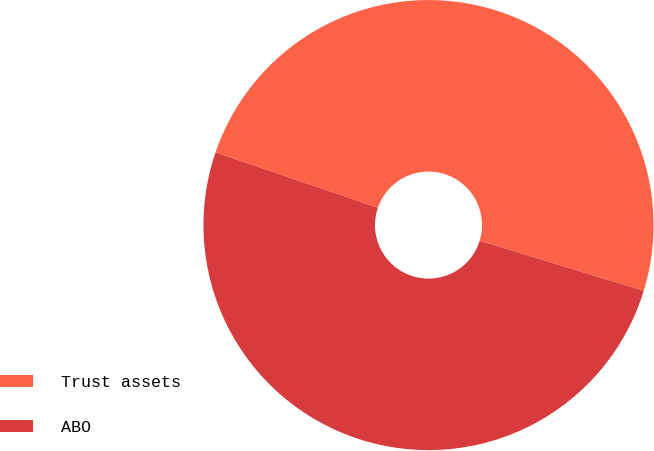Convert chart to OTSL. <chart><loc_0><loc_0><loc_500><loc_500><pie_chart><fcel>Trust assets<fcel>ABO<nl><fcel>49.49%<fcel>50.51%<nl></chart> 